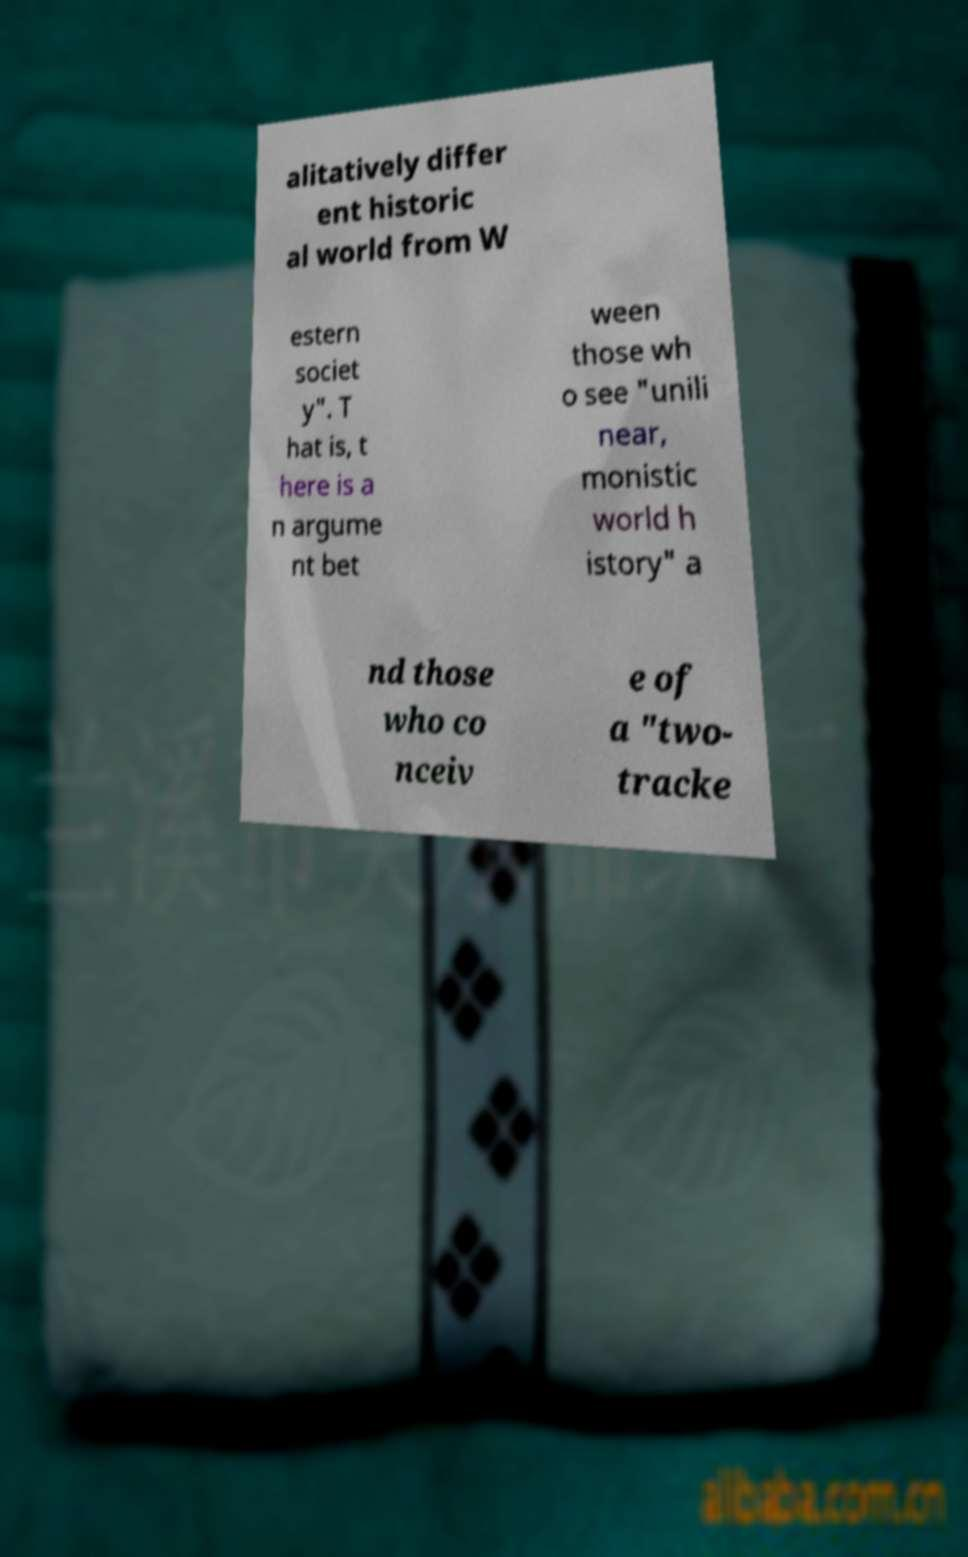Can you accurately transcribe the text from the provided image for me? alitatively differ ent historic al world from W estern societ y". T hat is, t here is a n argume nt bet ween those wh o see "unili near, monistic world h istory" a nd those who co nceiv e of a "two- tracke 